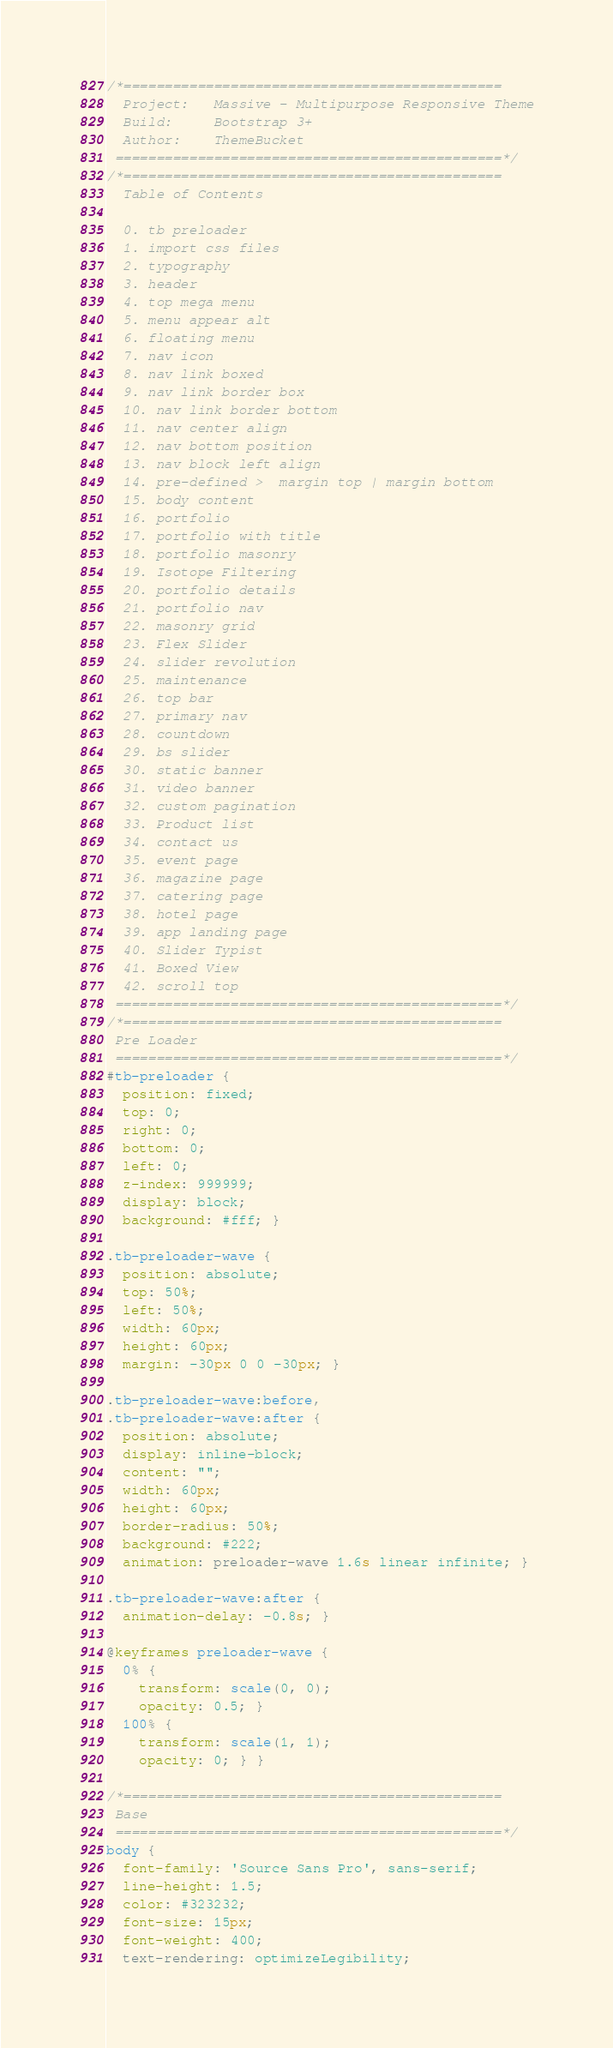<code> <loc_0><loc_0><loc_500><loc_500><_CSS_>/*==============================================
  Project:   Massive - Multipurpose Responsive Theme
  Build:     Bootstrap 3+
  Author:    ThemeBucket
 ===============================================*/
/*==============================================
  Table of Contents

  0. tb preloader
  1. import css files
  2. typography
  3. header
  4. top mega menu
  5. menu appear alt
  6. floating menu
  7. nav icon
  8. nav link boxed
  9. nav link border box
  10. nav link border bottom
  11. nav center align
  12. nav bottom position
  13. nav block left align
  14. pre-defined >  margin top | margin bottom
  15. body content
  16. portfolio
  17. portfolio with title
  18. portfolio masonry
  19. Isotope Filtering
  20. portfolio details
  21. portfolio nav
  22. masonry grid
  23. Flex Slider
  24. slider revolution
  25. maintenance
  26. top bar
  27. primary nav
  28. countdown
  29. bs slider
  30. static banner
  31. video banner
  32. custom pagination
  33. Product list
  34. contact us
  35. event page
  36. magazine page
  37. catering page
  38. hotel page
  39. app landing page
  40. Slider Typist
  41. Boxed View
  42. scroll top
 ===============================================*/
/*==============================================
 Pre Loader
 ===============================================*/
#tb-preloader {
  position: fixed;
  top: 0;
  right: 0;
  bottom: 0;
  left: 0;
  z-index: 999999;
  display: block;
  background: #fff; }

.tb-preloader-wave {
  position: absolute;
  top: 50%;
  left: 50%;
  width: 60px;
  height: 60px;
  margin: -30px 0 0 -30px; }

.tb-preloader-wave:before,
.tb-preloader-wave:after {
  position: absolute;
  display: inline-block;
  content: "";
  width: 60px;
  height: 60px;
  border-radius: 50%;
  background: #222;
  animation: preloader-wave 1.6s linear infinite; }

.tb-preloader-wave:after {
  animation-delay: -0.8s; }

@keyframes preloader-wave {
  0% {
    transform: scale(0, 0);
    opacity: 0.5; }
  100% {
    transform: scale(1, 1);
    opacity: 0; } }

/*==============================================
 Base
 ===============================================*/
body {
  font-family: 'Source Sans Pro', sans-serif;
  line-height: 1.5;
  color: #323232;
  font-size: 15px;
  font-weight: 400;
  text-rendering: optimizeLegibility;</code> 